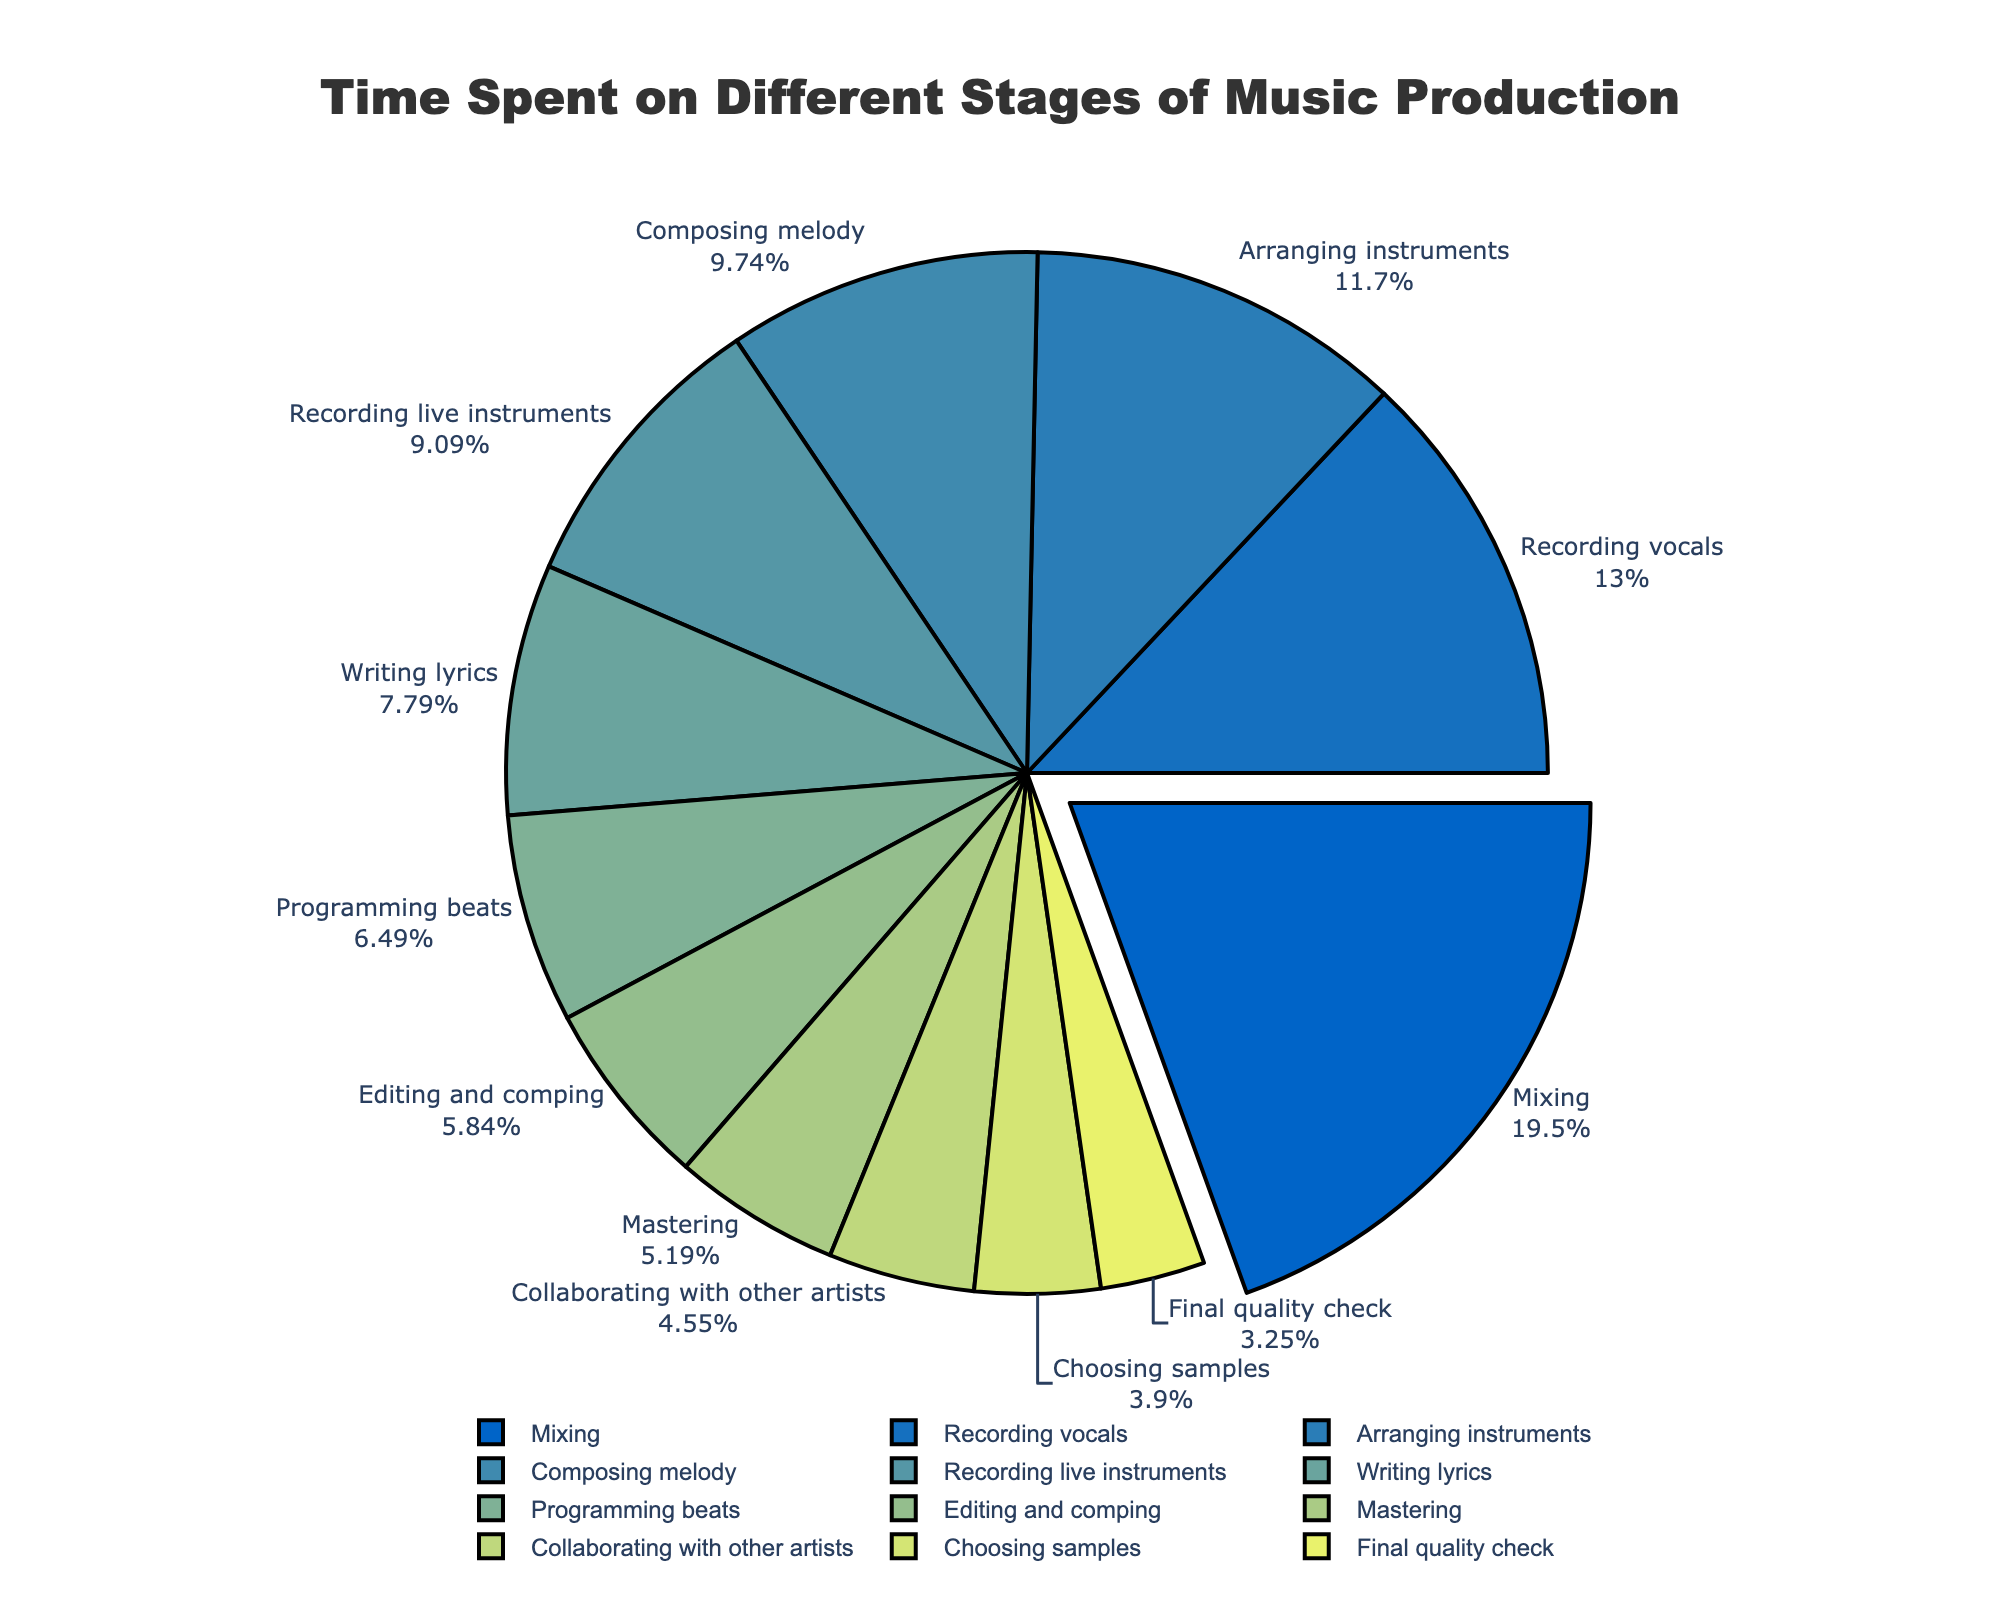What is the stage with the highest number of hours spent? The stage with the highest number of hours spent can be determined by looking at the largest segment in the pie chart. This segment is "Mixing", accounting for the highest percentage of the circle.
Answer: Mixing Which stages take more than 15 hours? To determine which stages take more than 15 hours, look at the segments in the pie chart that correspond to values greater than 15. These are "Mixing" (30), "Recording vocals" (20), and "Arranging instruments" (18).
Answer: Mixing, Recording vocals, Arranging instruments How much time, in total, is spent on Composing melody and Writing lyrics? To find the total time spent on these stages, add the hours for "Composing melody" (15) and "Writing lyrics" (12). Thus, the total is 15 + 12 = 27 hours.
Answer: 27 How does the time spent on Editing and comping compare to Programming beats? Look at the segments for "Editing and comping" and "Programming beats". "Editing and comping" takes 9 hours, while "Programming beats" takes 10 hours. Therefore, Programming beats takes 1 hour more than Editing and comping.
Answer: Programming beats takes 1 hour more Which stage has the smallest percentage of time spent? The smallest segment in the pie chart corresponds to the stage with the least hours. This is "Final quality check", which has only 5 hours logged.
Answer: Final quality check What is the average time spent on all stages? To find the average, first sum the hours for all stages: 20 + 30 + 15 + 12 + 18 + 8 + 10 + 14 + 6 + 9 + 7 + 5 = 154 hours. There are 12 stages, so the average time spent is 154 / 12 ≈ 12.83 hours.
Answer: 12.83 hours Compare the time spent on Collaborating with other artists and Choosing samples. Which one is higher and by how much? "Collaborating with other artists" takes 7 hours and "Choosing samples" takes 6 hours. By subtracting these values, we find that Collaborating with other artists takes 1 hour more.
Answer: Collaborating with other artists by 1 hour What is the total percentage of time spent on Recording vocals, Arranging instruments, and Recording live instruments combined? The percentages can be estimated by summing the individual percentages from the pie chart: "Recording vocals" (20 hours, ~13%), "Arranging instruments" (18 hours, ~11.7%), and "Recording live instruments" (14 hours, ~9.1%). The total percentage is roughly 13 + 11.7 + 9.1 = 33.8%.
Answer: 33.8% 